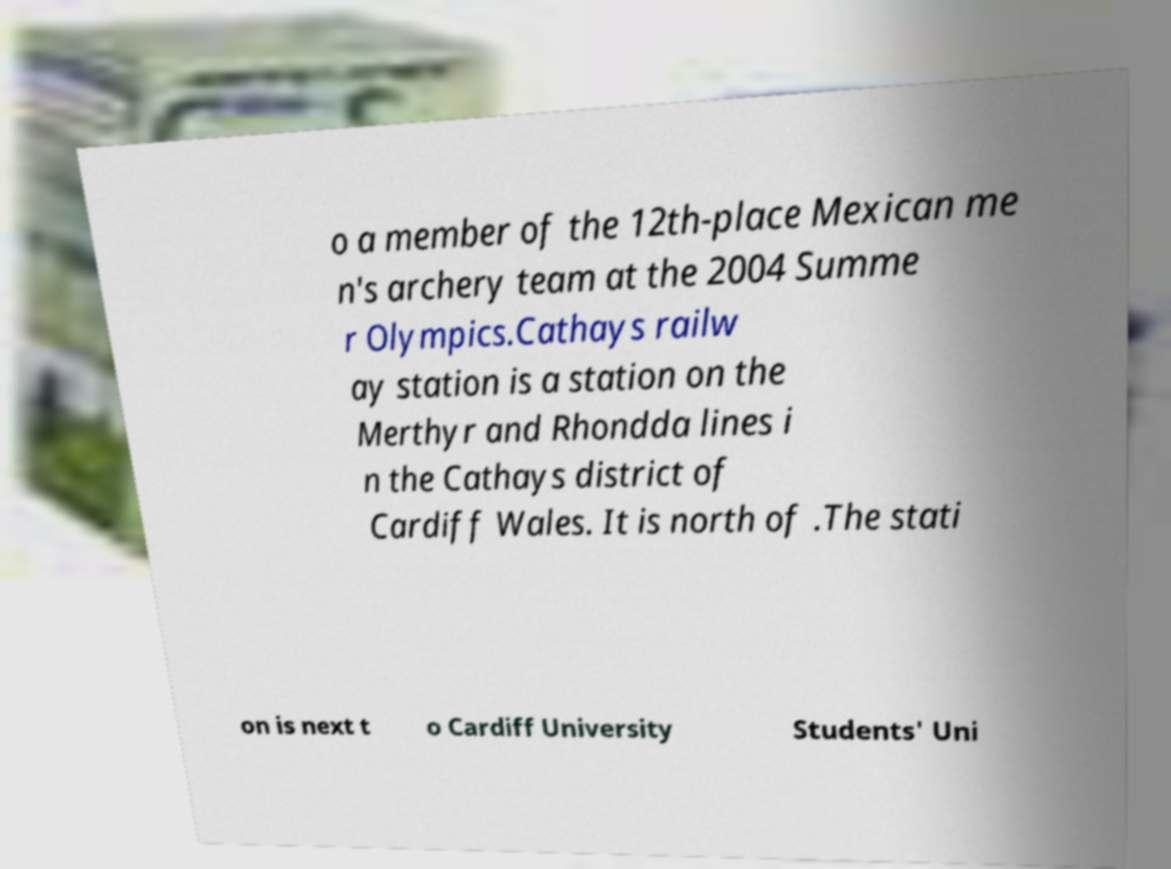Can you accurately transcribe the text from the provided image for me? o a member of the 12th-place Mexican me n's archery team at the 2004 Summe r Olympics.Cathays railw ay station is a station on the Merthyr and Rhondda lines i n the Cathays district of Cardiff Wales. It is north of .The stati on is next t o Cardiff University Students' Uni 